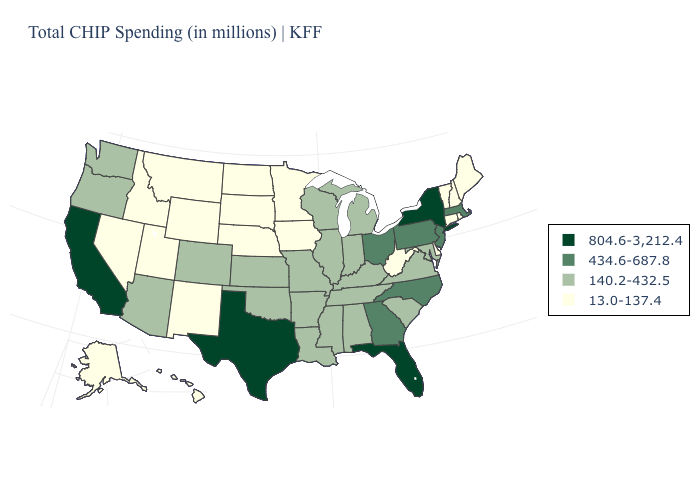Name the states that have a value in the range 13.0-137.4?
Quick response, please. Alaska, Connecticut, Delaware, Hawaii, Idaho, Iowa, Maine, Minnesota, Montana, Nebraska, Nevada, New Hampshire, New Mexico, North Dakota, Rhode Island, South Dakota, Utah, Vermont, West Virginia, Wyoming. What is the value of New York?
Give a very brief answer. 804.6-3,212.4. Name the states that have a value in the range 804.6-3,212.4?
Concise answer only. California, Florida, New York, Texas. What is the lowest value in the Northeast?
Short answer required. 13.0-137.4. How many symbols are there in the legend?
Answer briefly. 4. Is the legend a continuous bar?
Write a very short answer. No. Name the states that have a value in the range 434.6-687.8?
Short answer required. Georgia, Massachusetts, New Jersey, North Carolina, Ohio, Pennsylvania. Among the states that border Michigan , does Ohio have the lowest value?
Concise answer only. No. What is the value of Alaska?
Concise answer only. 13.0-137.4. What is the value of Nevada?
Answer briefly. 13.0-137.4. Among the states that border New Hampshire , which have the lowest value?
Give a very brief answer. Maine, Vermont. Which states have the lowest value in the USA?
Concise answer only. Alaska, Connecticut, Delaware, Hawaii, Idaho, Iowa, Maine, Minnesota, Montana, Nebraska, Nevada, New Hampshire, New Mexico, North Dakota, Rhode Island, South Dakota, Utah, Vermont, West Virginia, Wyoming. What is the value of Connecticut?
Answer briefly. 13.0-137.4. Does Colorado have a lower value than New York?
Short answer required. Yes. Does Texas have the highest value in the South?
Answer briefly. Yes. 